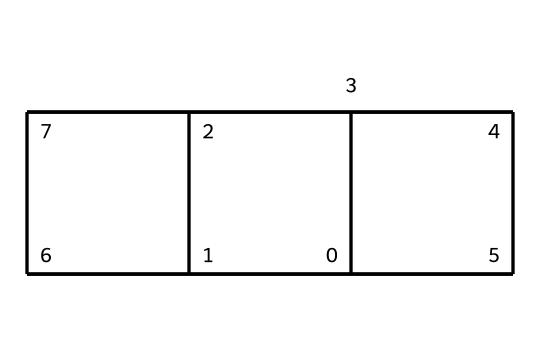How many carbon atoms are present in cubane? The SMILES representation indicates the presence of multiple carbon atoms connected in a cage-like structure. Analyzing the structure shows that there are 8 carbon atoms, as each carbon in the SMILES corresponds to a vertex in the cubic arrangement.
Answer: 8 What is the basic shape of cubane? Cubane's structure reveals it forms a cubic geometry due to its arrangement of 8 carbon atoms. Each bonded atom connects to four others in a three-dimensional configuration resembling a cube.
Answer: cubic Is cubane a saturated or unsaturated compound? The structure shows all carbon atoms are bonded with single bonds to their neighboring atoms, indicating that there are no double or triple bonds. Therefore, cubane is classified as a saturated compound.
Answer: saturated What type of bonding can be seen in cubane? The SMILES notation and structure indicate that cubane features only single covalent bonds between the carbon atoms and also with hydrogen atoms, without the presence of any double or triple bonds.
Answer: single covalent bonds What is the potential use of cubane in military applications? Cubane is regarded for its high energy density due to its compact and stable structure, making it a candidate for high-performance explosives and propellants in military technology.
Answer: military explosives How does the cage structure of cubane affect its stability? The distinctive cage structure allows for a stable arrangement of atoms, making cubane less reactive under certain conditions compared to linear or branched compounds. This unique stability contributes to its potential as a high-energy explosive.
Answer: increased stability 